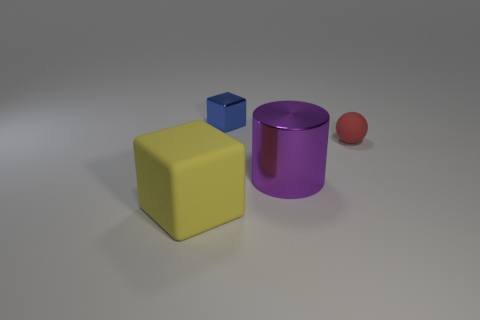What number of blue shiny blocks are to the left of the small object left of the tiny object right of the blue metal thing?
Provide a succinct answer. 0. What is the color of the big block that is the same material as the sphere?
Your response must be concise. Yellow. Do the metallic thing that is right of the blue shiny object and the yellow cube have the same size?
Offer a very short reply. Yes. How many objects are either big cyan rubber cylinders or blue metallic objects?
Offer a terse response. 1. There is a block that is in front of the matte thing to the right of the yellow matte object to the left of the purple metallic cylinder; what is it made of?
Your answer should be compact. Rubber. What material is the large thing right of the small blue metallic cube?
Provide a short and direct response. Metal. Are there any metallic cylinders that have the same size as the ball?
Provide a short and direct response. No. Does the big thing that is on the right side of the shiny cube have the same color as the shiny cube?
Your answer should be compact. No. How many brown things are small shiny cylinders or shiny blocks?
Keep it short and to the point. 0. Does the big yellow cube have the same material as the large purple cylinder?
Give a very brief answer. No. 